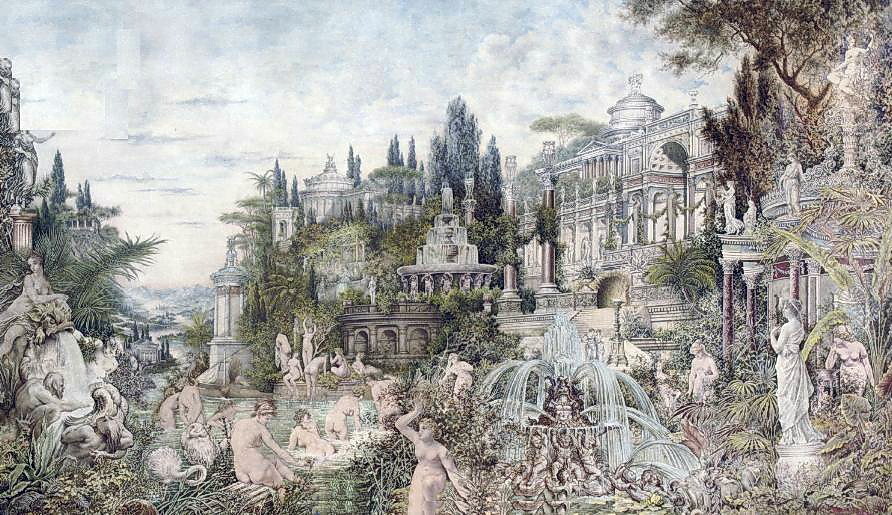Describe the following image. The image portrays an enchanting and whimsical landscape with a magnificent palace as its focal point. The palace, constructed in a grandiose style reminiscent of the Rococo period, is richly embellished with intricate details, standing proudly amidst lush, verdant gardens. These gardens are brimming with an array of elements that add depth to the scene: exquisitely crafted statues, dynamic fountains, and a diverse assortment of plants that infuse the image with vibrant colors.

Soft pastel tones, predominantly greens and blues, dominate the color scheme, enhancing the serene and peaceful ambiance. The combination of architectural splendor and natural beauty is spectacularly rendered, creating a harmonious and immersive tableau.

This piece can be categorized as a landscape artwork, concentrating on both the architectural intricacies of the palace and the luxuriant natural surroundings. The synthesis of these elements is a hallmark of landscape art, illustrating a meticulous and captivating representation of an imaginative setting. 